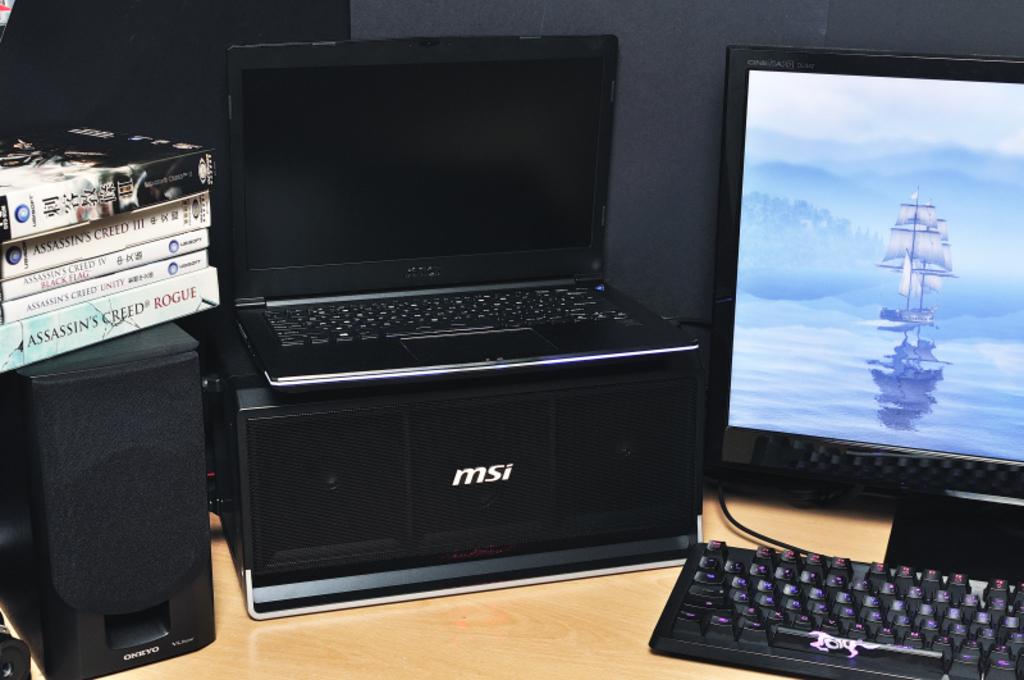What speaker brand is the speaker?
Your response must be concise. Msi. What video game box is on the bottom?
Give a very brief answer. Msi. 